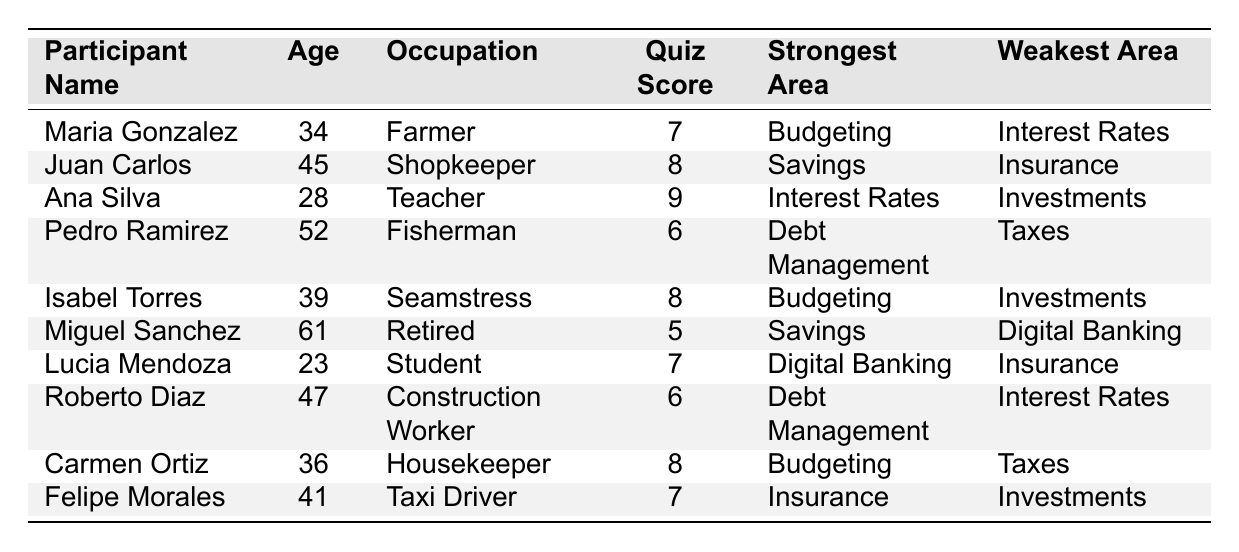What was the highest quiz score achieved by a participant? The highest quiz score from the table is found by scanning the "Quiz Score" column to identify the highest value. The highest score is 9, achieved by Ana Silva.
Answer: 9 How many participants scored below 7 on the quiz? To answer this, we need to count the number of participants with quiz scores less than 7. Maria Gonzalez (7), Pedro Ramirez (6), Miguel Sanchez (5), and Roberto Diaz (6) are below this threshold, totaling 3 participants.
Answer: 3 Which occupation had the participant with the lowest quiz score? The participant with the lowest quiz score is Miguel Sanchez with a score of 5, and he is a Retired individual. We identify his occupation by checking the corresponding row for the score.
Answer: Retired What is the median quiz score of the participants? To find the median, first list all scores in ascending order: 5, 6, 6, 7, 7, 7, 8, 8, 8, 9. Since there are 10 scores, the median will be the average of the 5th and 6th scores, which are both 7. Therefore, (7 + 7) / 2 = 7.
Answer: 7 Is there a participant who excels in "Investments"? If so, who? By reviewing the "Strongest Area" column, we see that Ana Silva lists "Interest Rates" as her strongest area. Isabel Torres and Felipe Morales mention "Investments" as their weakest area, indicating no one excels in this area.
Answer: No Which participant has the strongest area in "Savings" and what is their weakest area? From the data, Juan Carlos has "Savings" as his strongest area, and his weakest area is "Insurance." This information is gathered by finding the corresponding row for Juan Carlos.
Answer: Juan Carlos, Insurance How many participants reported "Budgeting" as their strongest area? We count the occurrences of "Budgeting" in the "Strongest Area" column: Maria Gonzalez, Isabel Torres, and Carmen Ortiz all list "Budgeting," resulting in a total of 3 participants.
Answer: 3 Which participant has the lowest scores in "Digital Banking" and what score did they achieve? Checking the "Weakest Area" column, Miguel Sanchez lists "Digital Banking" as his weakest area with a quiz score of 5. This requires an examination of both columns to link the areas and scores.
Answer: Miguel Sanchez, 5 Determine the average age of participants who scored 8 or higher on the quiz. Identify the participants who scored 8 or more: Juan Carlos (45), Ana Silva (28), Isabel Torres (39), Carmen Ortiz (36). Their ages are summed as 45 + 28 + 39 + 36 = 148, and since there are 4 participants, the average age is 148 / 4 = 37.
Answer: 37 What percentage of participants had "Interest Rates" as their weakest area? Of the 10 participants, 2 (Maria Gonzalez and Roberto Diaz) have "Interest Rates" as their weakest area. To find the percentage, we calculate (2 / 10) * 100 = 20%.
Answer: 20% 